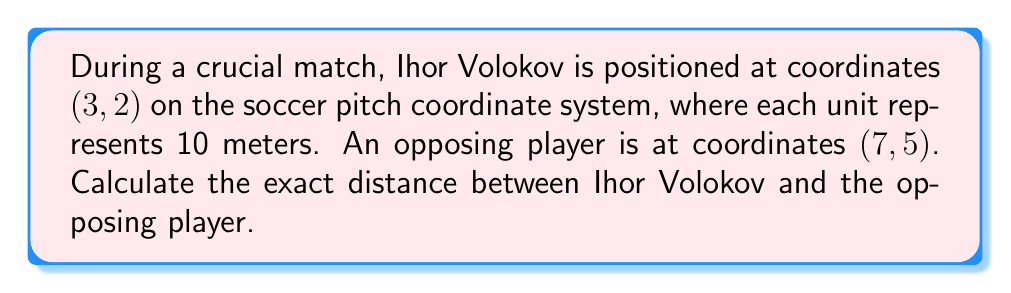What is the answer to this math problem? To solve this problem, we'll use the distance formula derived from the Pythagorean theorem. The distance formula for two points $(x_1, y_1)$ and $(x_2, y_2)$ is:

$$d = \sqrt{(x_2 - x_1)^2 + (y_2 - y_1)^2}$$

Let's plug in the coordinates:
- Ihor Volokov: $(x_1, y_1) = (3, 2)$
- Opposing player: $(x_2, y_2) = (7, 5)$

Now, let's calculate:

$$\begin{align}
d &= \sqrt{(7 - 3)^2 + (5 - 2)^2} \\
&= \sqrt{4^2 + 3^2} \\
&= \sqrt{16 + 9} \\
&= \sqrt{25} \\
&= 5
\end{align}$$

Since each unit represents 10 meters, we multiply our result by 10:

$$5 \times 10 = 50\text{ meters}$$

[asy]
unitsize(1cm);
draw((-1,-1)--(8,6), gray);
draw((0,0)--(8,0)--(8,6)--(0,6)--cycle);
dot((3,2),red);
dot((7,5),blue);
label("Ihor Volokov (3,2)", (3,2), SE, red);
label("Opponent (7,5)", (7,5), NW, blue);
draw((3,2)--(7,5), dashed);
[/asy]
Answer: The exact distance between Ihor Volokov and the opposing player is 50 meters. 